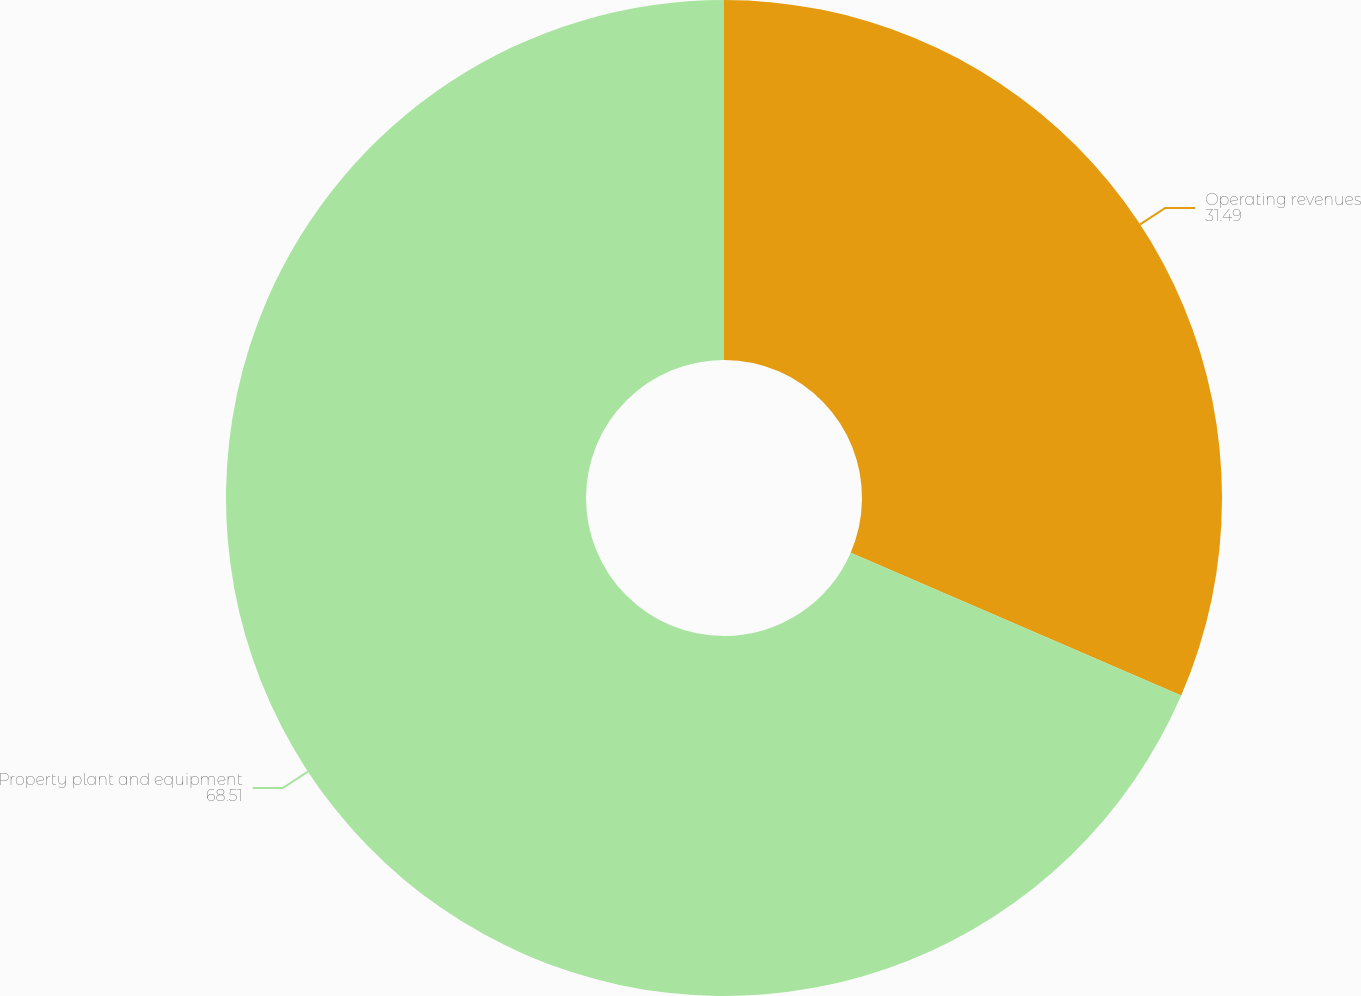<chart> <loc_0><loc_0><loc_500><loc_500><pie_chart><fcel>Operating revenues<fcel>Property plant and equipment<nl><fcel>31.49%<fcel>68.51%<nl></chart> 